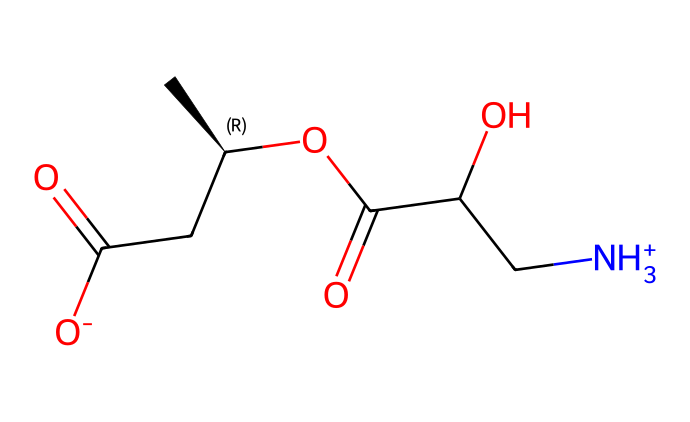What is the molecular formula of L-carnitine? The SMILES representation indicates the number of each atom present in the compound: carbon (C), hydrogen (H), nitrogen (N), and oxygen (O) can be counted to derive the molecular formula. From the SMILES, there are 7 carbon atoms, 15 hydrogen atoms, 1 nitrogen atom, and 4 oxygen atoms, resulting in the formula C7H15N1O4.
Answer: C7H15NO4 How many stereocenters are present in L-carnitine? The structure shows that there is one chiral carbon atom, which is indicated by the notation "(C@H)" in the SMILES. A stereocenter, or chiral center, is a carbon atom bonded to four different substituents. In this case, there is only one.
Answer: 1 What type of functional groups are present in L-carnitine? By analyzing the SMILES, we can identify several functional groups: a carboxylic acid (—COOH), alcohol (—OH), and amine (—NH3+). The presence of these groups indicates the various chemical reactivity and properties of L-carnitine.
Answer: carboxylic acid, alcohol, amine What is the charge of L-carnitine at physiological pH? The SMILES indicates the presence of a positively charged ammonium group ([NH3+]) and a negatively charged carboxylate ([O-]). At physiological pH, the compound would typically exist as a zwitterion, balancing the charges. Therefore, L-carnitine has a net charge of zero.
Answer: 0 Is L-carnitine a coordination compound? L-carnitine does not fit the definition of a coordination compound, as it does not contain a central metal atom bonded to surrounding ligands. Coordination compounds typically involve metal complexes, which is not the case here.
Answer: No What is the significance of the hydroxyl group in L-carnitine? The hydroxyl group (—OH) contributes to the solubility and interaction of L-carnitine with other biochemical compounds. It plays a role in hydrogen bonding, making the molecule more soluble in polar solvents such as water.
Answer: Solubility How is L-carnitine involved in fat metabolism? L-carnitine's structure includes a carboxylic acid moiety, which is essential for its role in transporting fatty acids into the mitochondria for beta-oxidation, thereby enabling fat metabolism during exercise.
Answer: Fatty acid transport 